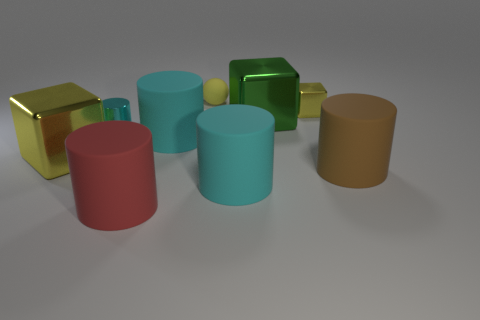Is there another thing of the same color as the small matte thing?
Make the answer very short. Yes. What is the size of the other block that is the same color as the tiny shiny block?
Your answer should be very brief. Large. There is a cyan object that is on the right side of the small cyan shiny thing and behind the big yellow object; what is its shape?
Offer a terse response. Cylinder. Does the metallic cylinder have the same size as the rubber sphere?
Your answer should be compact. Yes. There is a small matte sphere; how many big green metal things are in front of it?
Provide a short and direct response. 1. Are there an equal number of large matte objects that are to the left of the tiny matte object and tiny things on the left side of the green metallic object?
Keep it short and to the point. Yes. Do the tiny metal thing that is to the right of the small metal cylinder and the large yellow thing have the same shape?
Provide a succinct answer. Yes. There is a yellow matte thing; is its size the same as the cyan rubber object behind the big brown matte object?
Your response must be concise. No. How many other objects are the same color as the rubber ball?
Offer a very short reply. 2. Are there any matte cylinders left of the big yellow object?
Your answer should be very brief. No. 